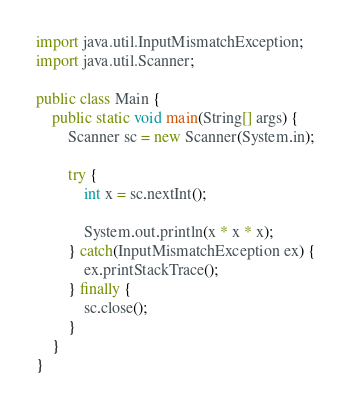<code> <loc_0><loc_0><loc_500><loc_500><_Java_>import java.util.InputMismatchException;
import java.util.Scanner;

public class Main {
	public static void main(String[] args) {
		Scanner sc = new Scanner(System.in);

		try {
			int x = sc.nextInt();

			System.out.println(x * x * x);
		} catch(InputMismatchException ex) {
			ex.printStackTrace();
		} finally {
			sc.close();
		}
	}
}

</code> 